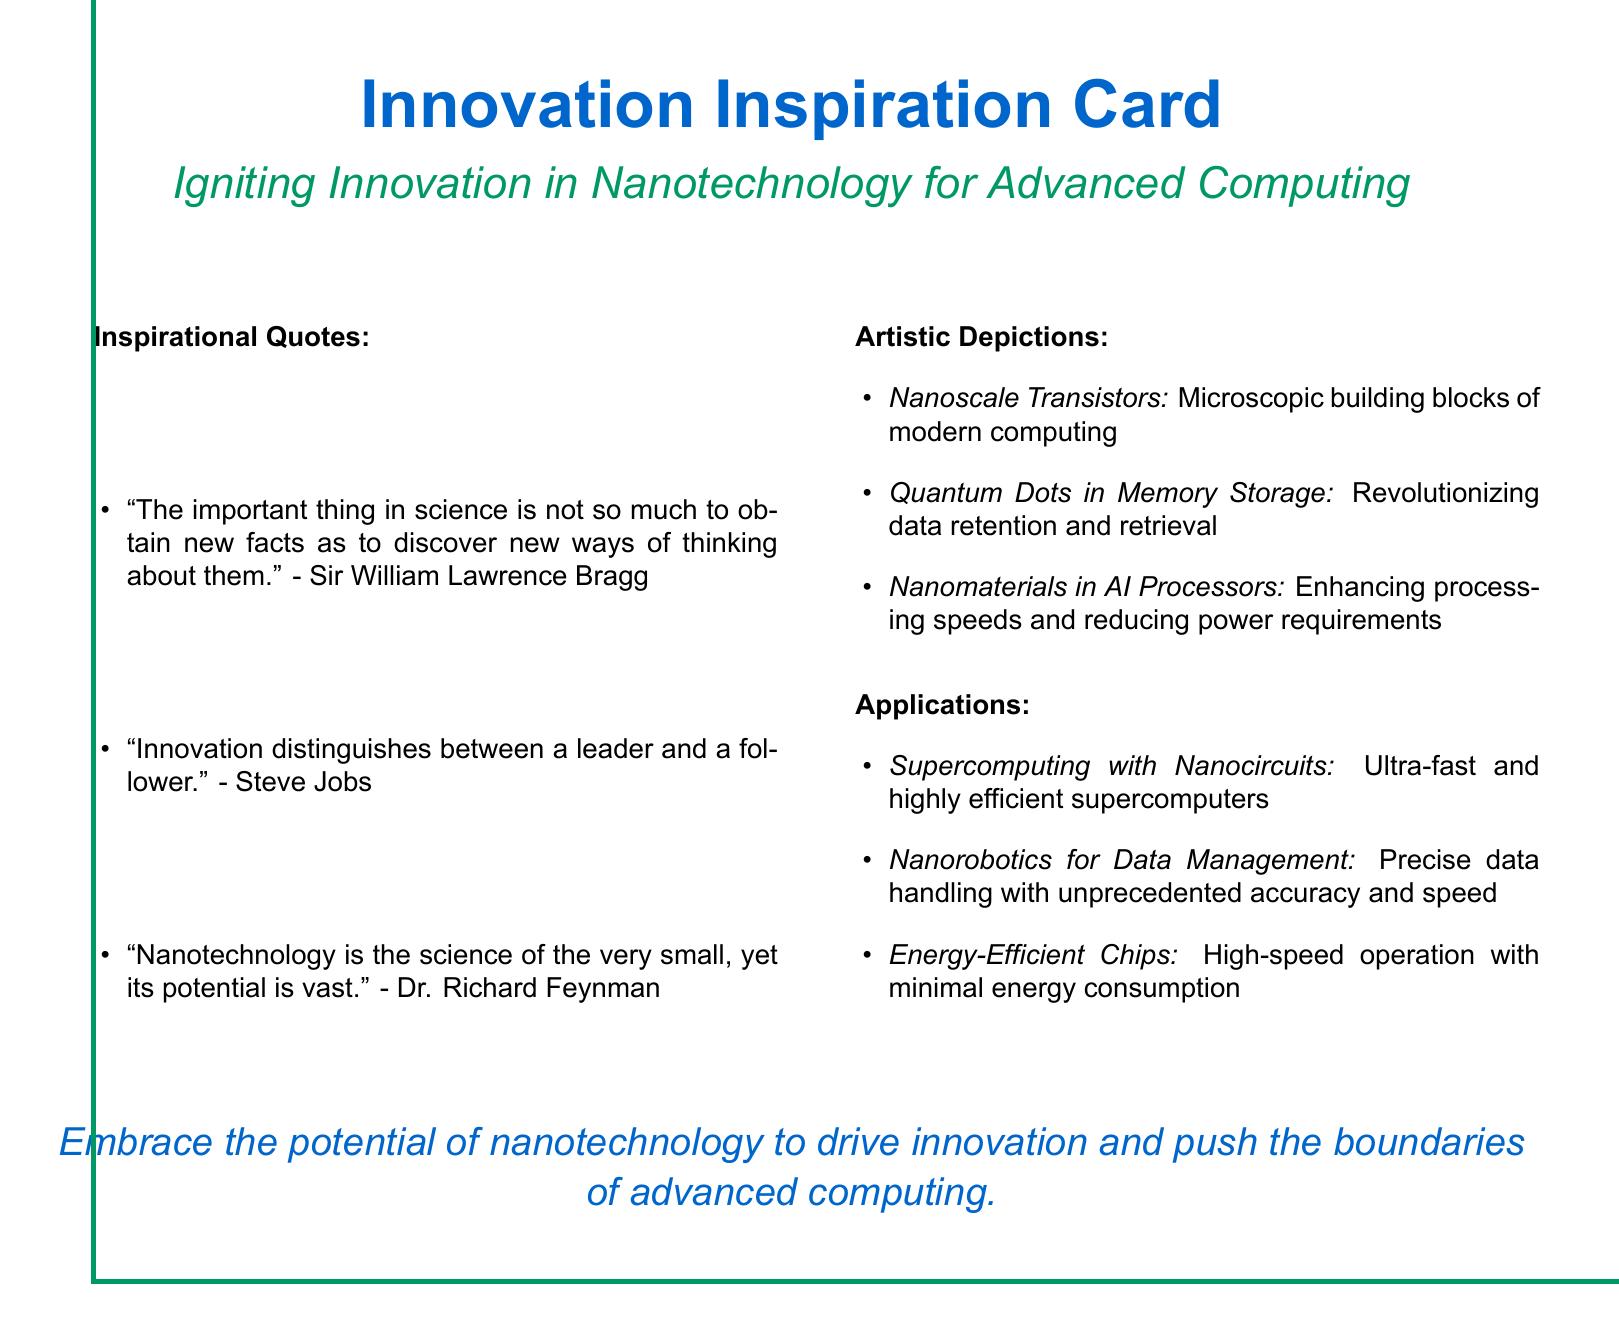What is the title of the card? The title is found at the top of the document, emphasizing the theme of innovation.
Answer: Innovation Inspiration Card Who is quoted about the importance of new ways of thinking? This quote emphasizes the significance of innovative thinking and is attributed to a notable scientist.
Answer: Sir William Lawrence Bragg How many inspirational quotes are listed? The number can be determined by counting the items in the Inspirational Quotes section.
Answer: Three What is a key application of nanotechnology mentioned in the card? This application pertains to modern computing systems, showcasing the benefits of nanotechnology.
Answer: Supercomputing with Nanocircuits Which famous figure is associated with the quote on innovation? This individual is known for their contributions to technology and innovation in the computing world.
Answer: Steve Jobs What color is used predominantly for the card's border? The color is defined in the document, serving as a visual element for the card's design.
Answer: NanoGreen Which scientist is quoted regarding the potential of nanotechnology? The quote emphasizes the vast potential of this field and is attributed to a renowned physicist.
Answer: Dr. Richard Feynman How many applications of nanotechnology are mentioned? The total can be found by counting the items listed in the Applications section.
Answer: Three 